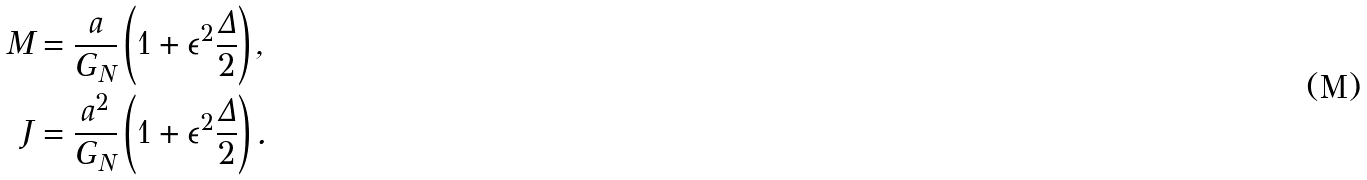Convert formula to latex. <formula><loc_0><loc_0><loc_500><loc_500>M & = \frac { a } { G _ { N } } \left ( 1 + \epsilon ^ { 2 } \frac { \Delta } { 2 } \right ) , \\ J & = \frac { a ^ { 2 } } { G _ { N } } \left ( 1 + \epsilon ^ { 2 } \frac { \Delta } { 2 } \right ) .</formula> 